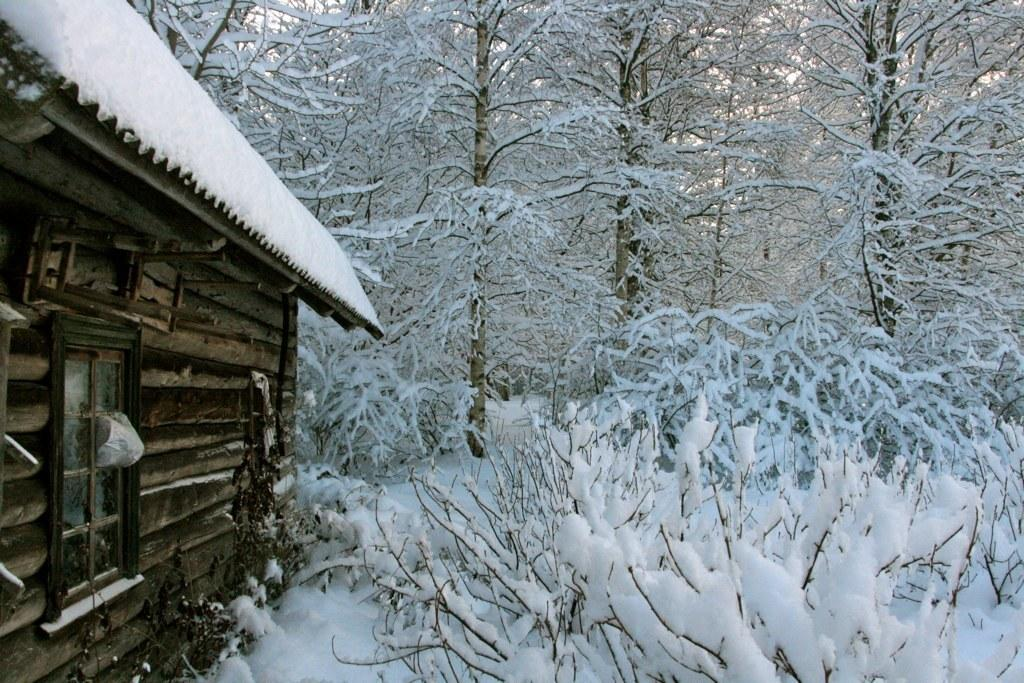What is located on the left side of the image? There is a hit on the left side of the image. What can be seen in the image that allows light to enter the room? There is a window in the image. What is covering the top of the structure in the image? There is a roof in the image. What type of vegetation can be seen in the background of the image? There are trees in the background of the image. What is the weather like in the image? The presence of snow in the background suggests that it is snowing or that there has been recent snowfall. What is the price of the straw in the image? There is no straw present in the image, so it is not possible to determine its price. How is the payment for the hit being processed in the image? There is no indication of payment or any financial transaction in the image. 